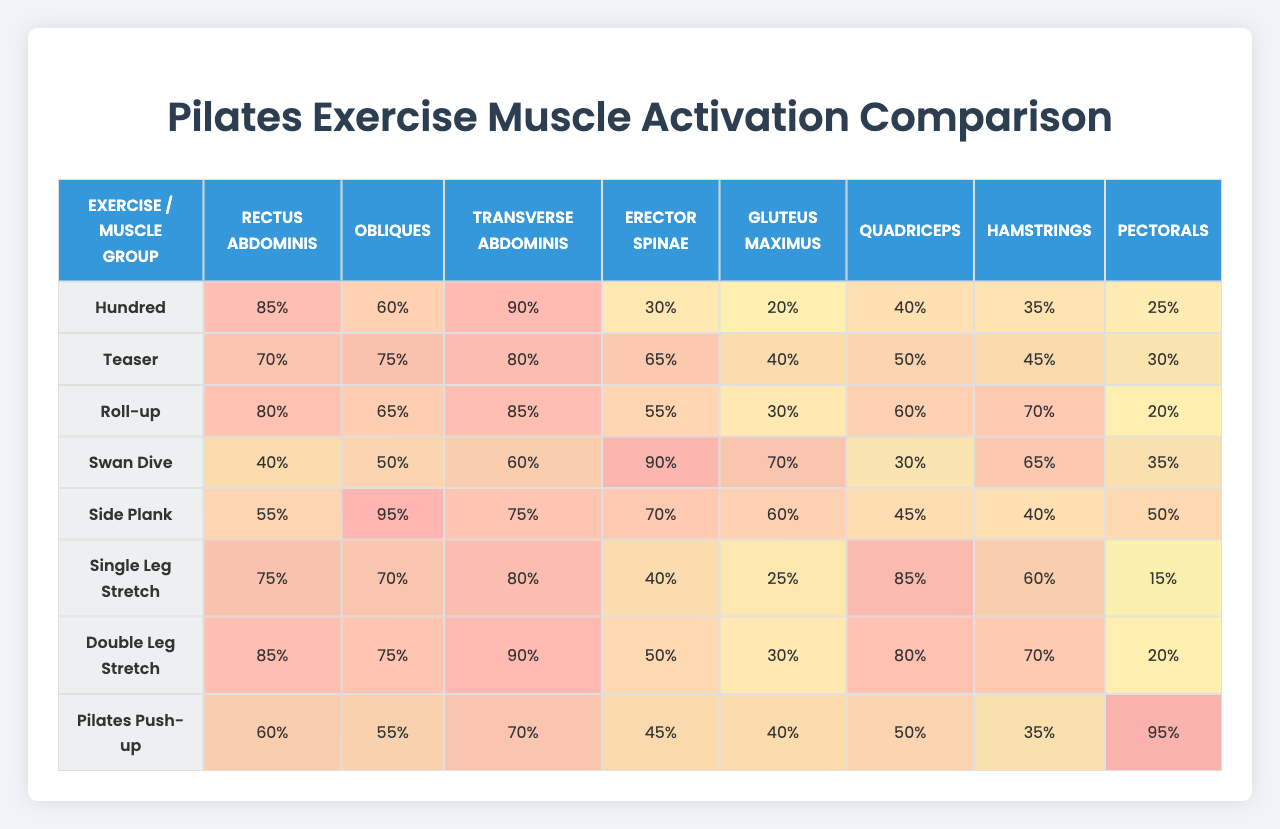What is the activation level of the Rectus Abdominis during the Teaser exercise? In the row corresponding to the Teaser exercise, the activation level for the Rectus Abdominis is listed as 70%.
Answer: 70% Which exercise activates the most Gluteus Maximus? The Side Plank exercise shows the highest activation level for Gluteus Maximus, which is 60%.
Answer: Side Plank What is the average activation level of the Obliques across all exercises? The activation levels for the Obliques are: 60 (Hundred), 75 (Teaser), 65 (Roll-up), 50 (Swan Dive), 95 (Side Plank), 70 (Single Leg Stretch), 75 (Double Leg Stretch), and 55 (Pilates Push-up). The sum is 60 + 75 + 65 + 50 + 95 + 70 + 75 + 55 = 605. There are 8 data points, so the average is 605 / 8 = 75.625%, which rounds to 76%.
Answer: 76% Is the activation level for Hamstrings higher in the Pilates Push-up or the Roll-up exercise? The Pilates Push-up exercise has an activation level of 35% for Hamstrings, while the Roll-up has 70%. Since 70% is greater than 35%, the Roll-up has a higher activation level for Hamstrings.
Answer: Roll-up What is the total activation level of the Rectus Abdominis across all exercises? The activation levels for Rectus Abdominis are: 85 (Hundred), 70 (Teaser), 80 (Roll-up), 40 (Swan Dive), 55 (Side Plank), 75 (Single Leg Stretch), 85 (Double Leg Stretch), and 60 (Pilates Push-up). Adding these gives 85 + 70 + 80 + 40 + 55 + 75 + 85 + 60 = 550%.
Answer: 550% Which muscle group has the lowest activation during the Swan Dive exercise? In the Swan Dive exercise row, the lowest activation level is for the Rectus Abdominis at 40%.
Answer: Rectus Abdominis How does the activation level of the Pectorals in the Single Leg Stretch compare to that in the Teaser? The activation level for Pectorals in the Single Leg Stretch is 15%, while in the Teaser it is 30%. Since 15% is less than 30%, the Single Leg Stretch has a lower activation level for Pectorals.
Answer: Lower in Single Leg Stretch Identify the exercise that has the highest activation for Quadriceps and state its level. The exercise with the highest activation level for Quadriceps is the Roll-up, which has an activation level of 70%.
Answer: Roll-up at 70% 